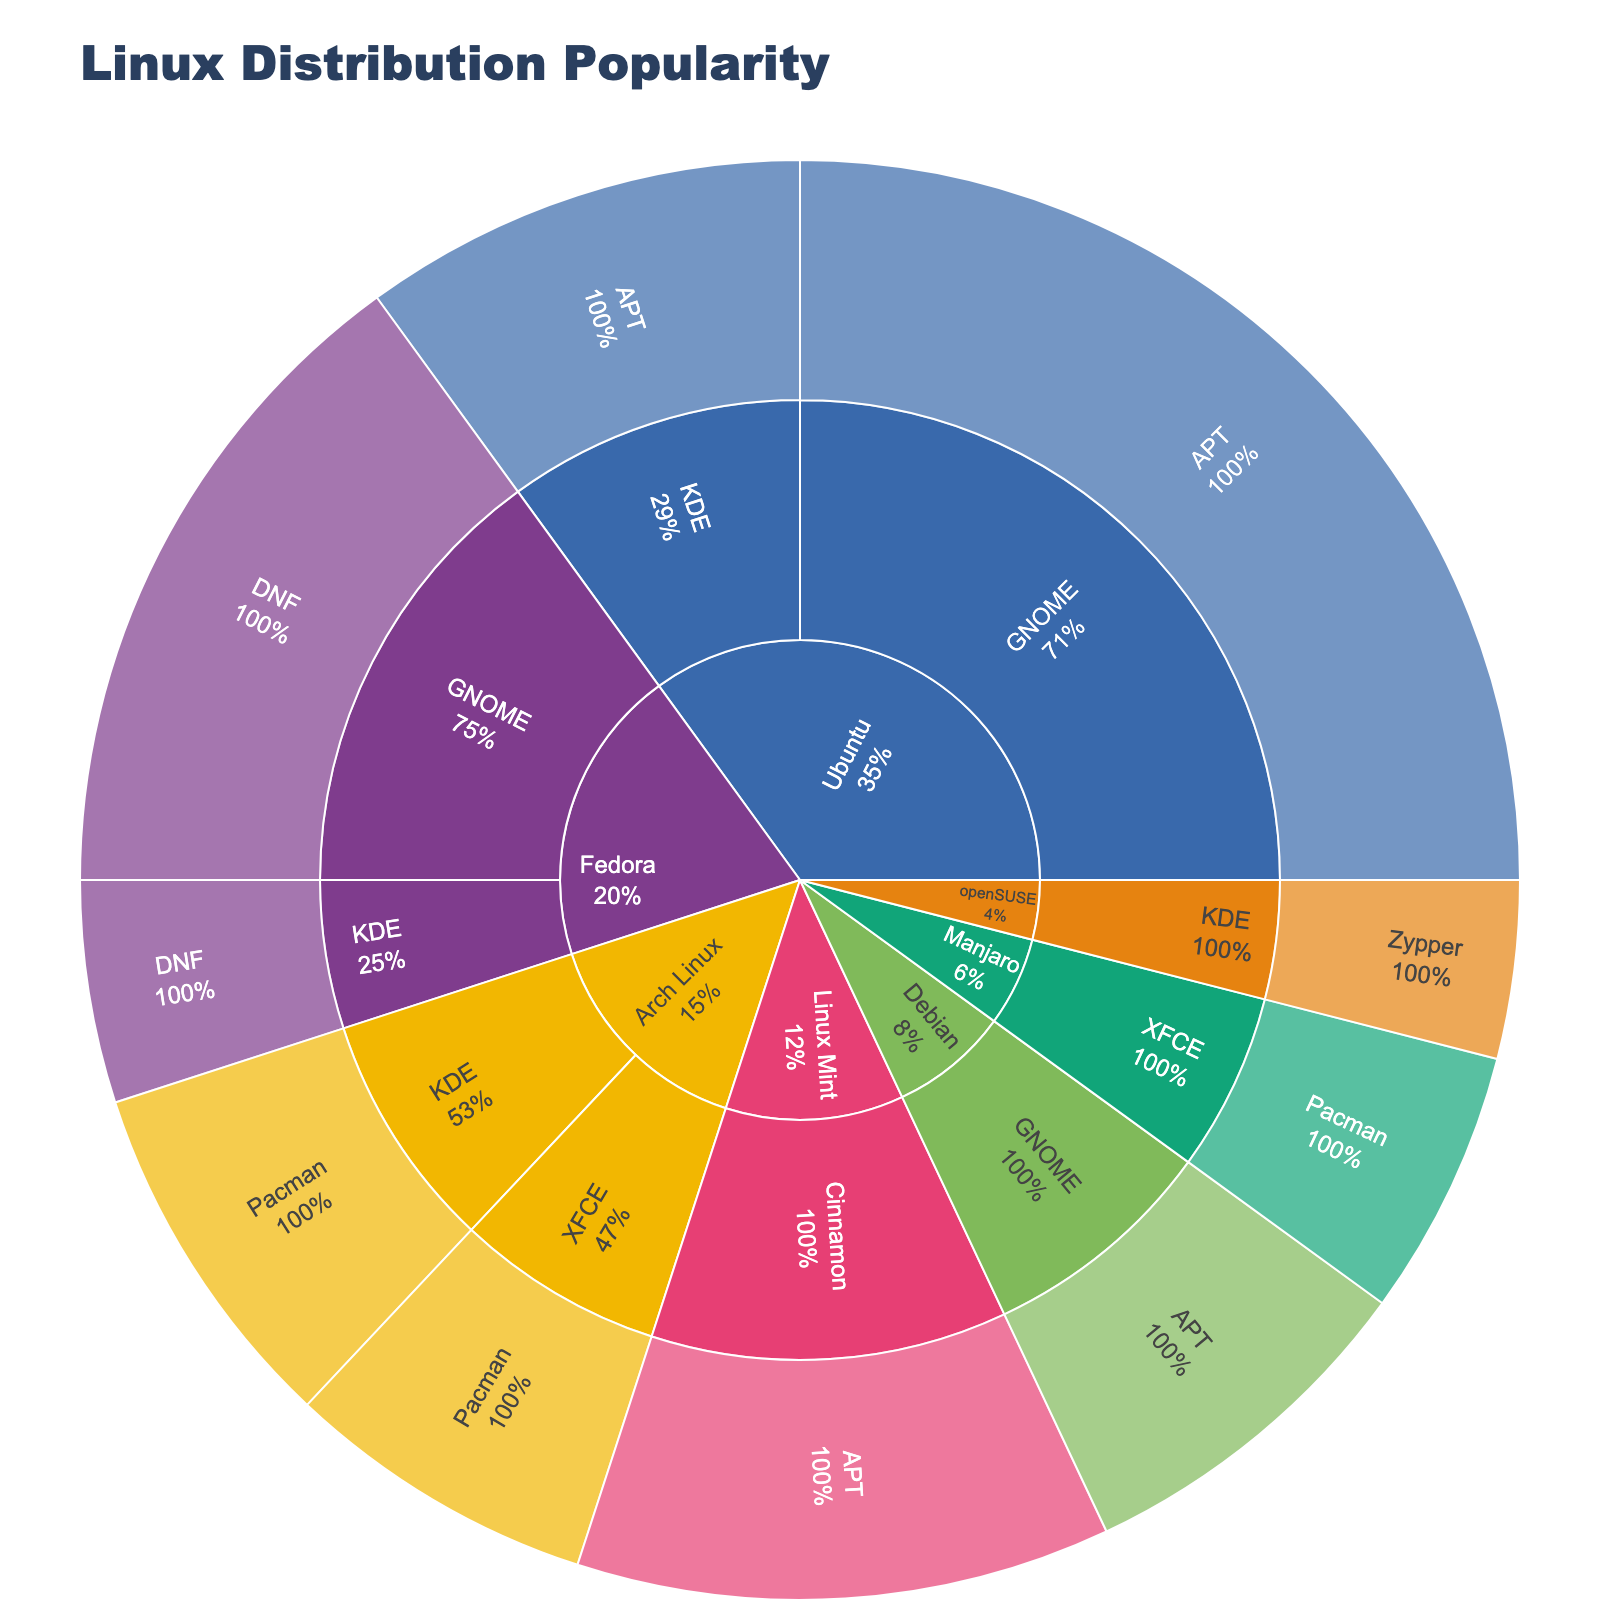Which Linux distribution has the highest usage overall? The sunburst plot shows the "Distribution" level, which reveals that Ubuntu has the largest segments overall, indicating the highest usage.
Answer: Ubuntu What percentage of GNOME's total usage comes from Ubuntu? First, locate the total usage for GNOME under Ubuntu and Fedora. GNOME on Ubuntu is 25 and on Fedora is 15. So, the total GNOME usage is 25 + 15 = 40. The percentage for Ubuntu's GNOME is (25 / 40) * 100%.
Answer: 62.5% Which desktop environment under Fedora has more usage? Look under Fedora, where GNOME shows 15 and KDE shows 5. Compare these values to identify the one with greater usage.
Answer: GNOME Is the usage of KDE in openSUSE higher than KDE in Arch Linux? Check both segments under KDE: openSUSE has a usage of 4, while Arch Linux has a usage of 8. Compare these figures.
Answer: No Add up all the distributions using the APT package manager. What's the total usage? Identify the APT segments under Ubuntu (25 + 10), Linux Mint (12), and Debian (8). Sum these up: 25 + 10 + 12 + 8 = 55.
Answer: 55 What is the least popular desktop environment for Arch Linux? Find the segments for Arch Linux: KDE with 8 and XFCE with 7. Determine the one with lesser usage.
Answer: XFCE What percentage of the total usage does Manjaro hold? Manjaro has a usage of 6. Add up all usage values: 25 + 10 + 15 + 5 + 8 + 7 + 12 + 6 + 8 + 4 = 100. The percentage for Manjaro is (6 / 100) * 100%.
Answer: 6% Which package manager is used most by Linux Mint? Linux Mint has only one segment under Cinnamon using APT with a usage of 12. The package manager is APT.
Answer: APT What is the difference in usage between KDE on Fedora and KDE on openSUSE? Identify the usage for KDE on Fedora, which is 5, and on openSUSE, which is 4. Subtract the openSUSE value from the Fedora value: 5 - 4 = 1.
Answer: 1 